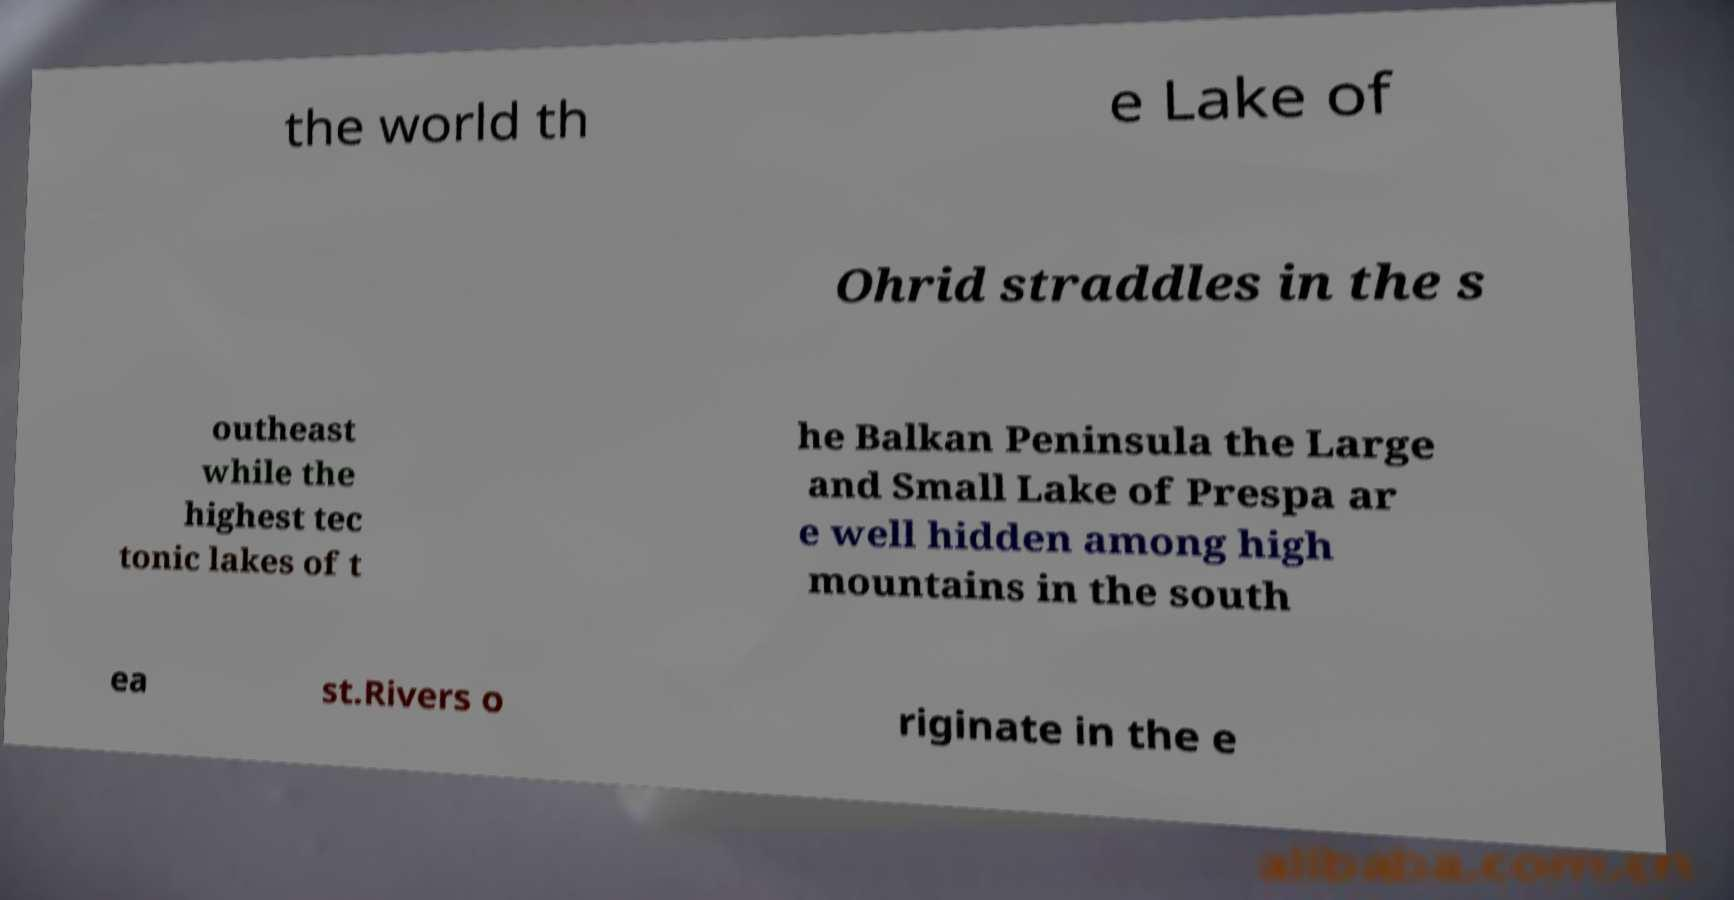Can you accurately transcribe the text from the provided image for me? the world th e Lake of Ohrid straddles in the s outheast while the highest tec tonic lakes of t he Balkan Peninsula the Large and Small Lake of Prespa ar e well hidden among high mountains in the south ea st.Rivers o riginate in the e 